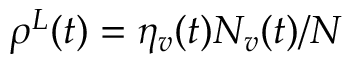<formula> <loc_0><loc_0><loc_500><loc_500>\rho ^ { L } ( t ) = \eta _ { v } ( t ) { N _ { v } ( t ) } / { N }</formula> 